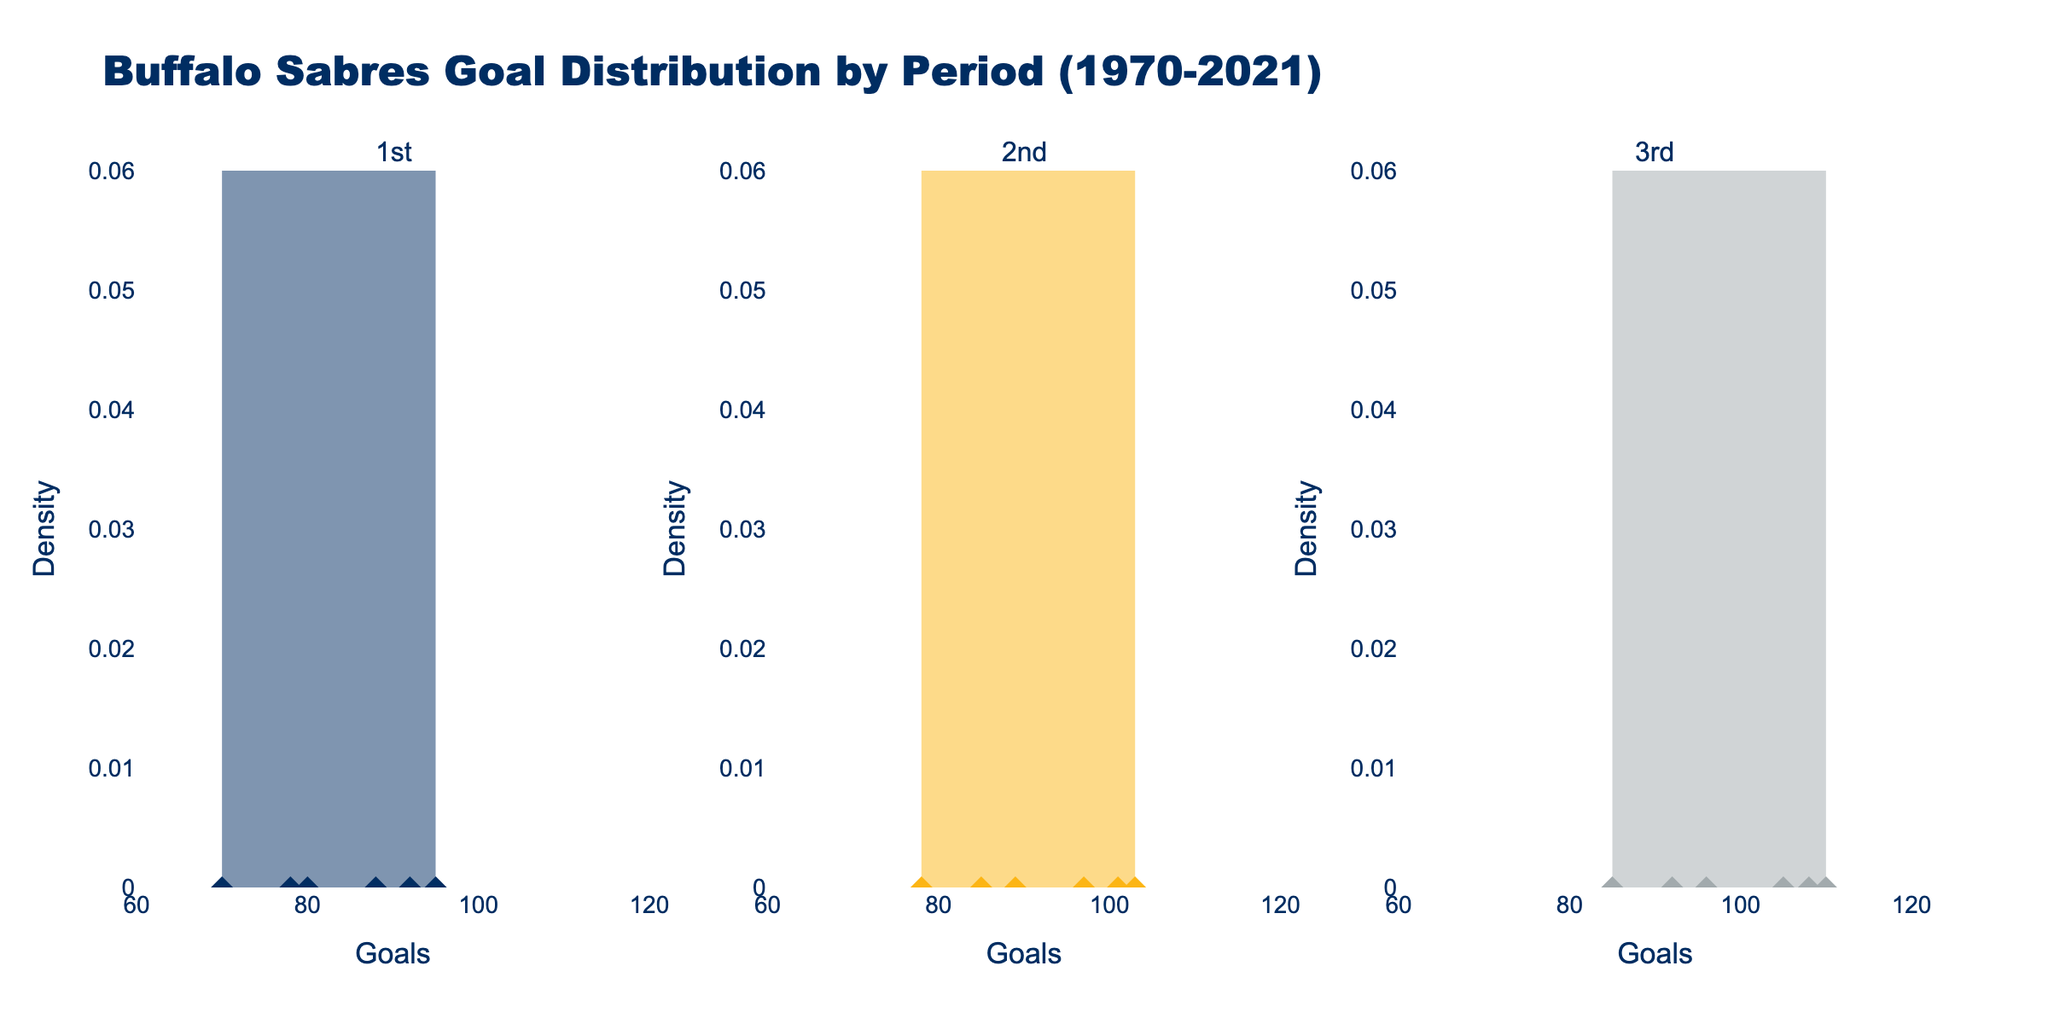What is the title of the figure? The title is usually located at the top of the figure, providing a summary of what the figure is about. Here, it indicates that the plot shows the goal distribution by period for the Buffalo Sabres over several seasons.
Answer: Buffalo Sabres Goal Distribution by Period (1970-2021) What are the labels on the x-axes? The x-axes labels indicate the variable plotted along the horizontal axis for each subplot. In this case, it's the number of goals scored.
Answer: Goals What is the highest density value seen in any period's density plot? Density plots show the distribution of data over a continuous interval. The highest density value is the peak of the curve in the density plots. By comparing the peaks of the curves, we can find the highest one.
Answer: 0.06 Which period has the widest range of goals? To determine the period with the widest range, we look at the horizontal spread of the data points in each period's subplot. The range is given by the difference between the highest and lowest goals in each period.
Answer: 3rd Period What is the average number of goals in the 2nd period for the seasons shown? To find the average number of goals, sum the goals for the 2nd period across all seasons and divide by the number of seasons. The seasons' goals for the 2nd period are (85, 103, 97, 101, 89, 78). The sum is 553, and there are 6 seasons.
Answer: 92.17 Which period shows the least variability in the number of goals? Variability can be assessed by observing the spread of the KDE plot. The period with the narrowest spread indicates the least variability. Additionally, the data points appear closer together.
Answer: 1st Period Are there any periods where goals show a positively skewed distribution? A positively skewed distribution has a long right tail. This can be observed if the density curve is higher on the left and stretches toward the right.
Answer: Yes, the 3rd period How many unique seasons are included in the data? The number of unique seasons can be counted from the dataset. Each subplot contains data from each unique season.
Answer: 6 In which period did the Buffalo Sabres score the most goals in the 2020-21 season? By looking at the individual data points from the 2020-21 season, we can identify the period with the highest number of goals.
Answer: 3rd Period, 85 goals 